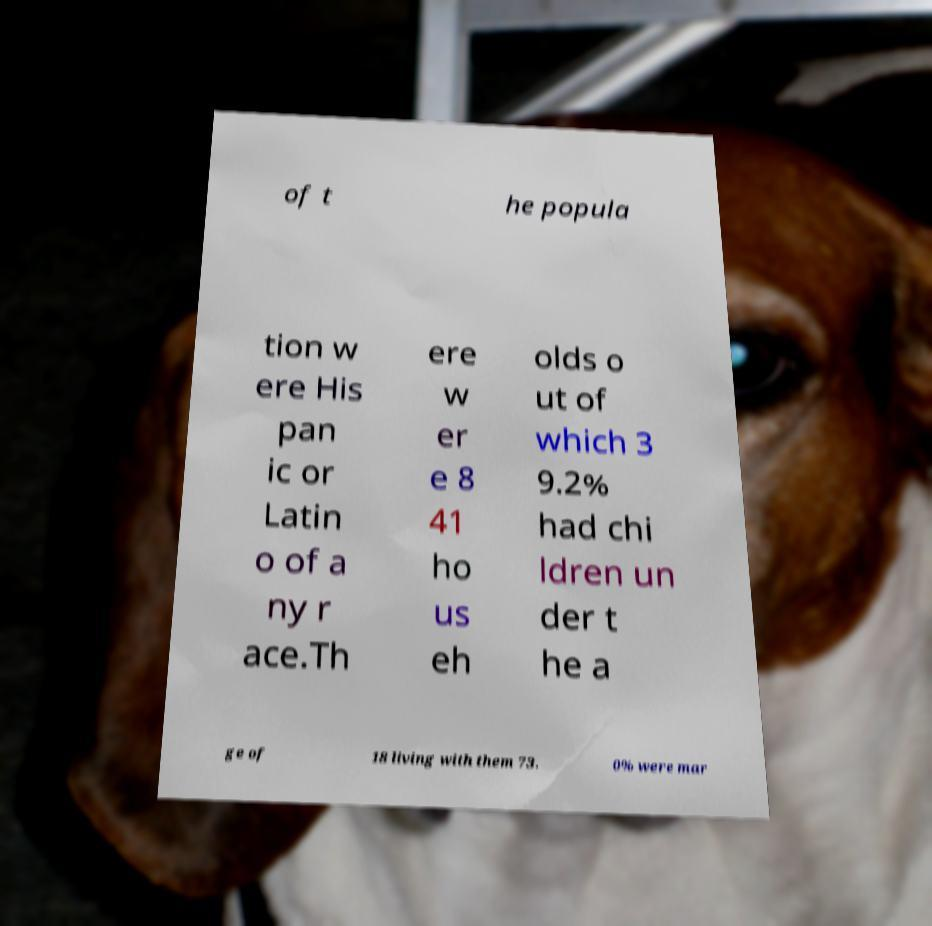For documentation purposes, I need the text within this image transcribed. Could you provide that? of t he popula tion w ere His pan ic or Latin o of a ny r ace.Th ere w er e 8 41 ho us eh olds o ut of which 3 9.2% had chi ldren un der t he a ge of 18 living with them 73. 0% were mar 